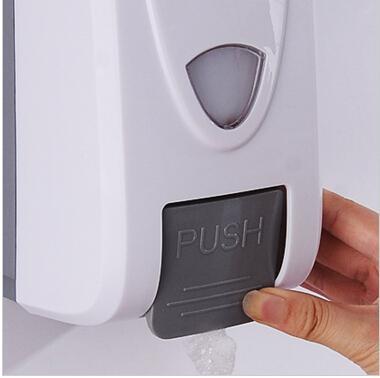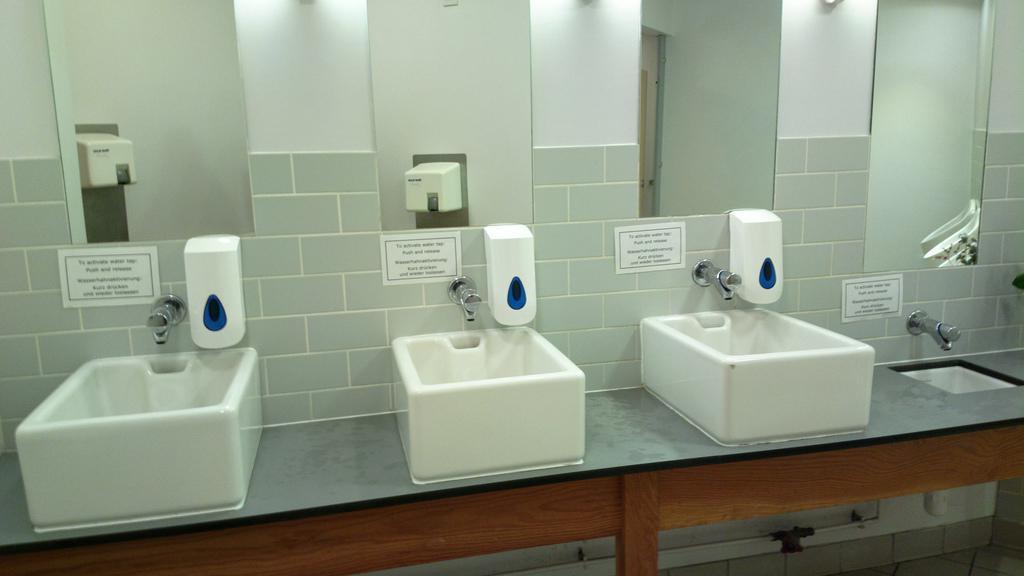The first image is the image on the left, the second image is the image on the right. Evaluate the accuracy of this statement regarding the images: "A person is pushing the dispenser in the image on the left.". Is it true? Answer yes or no. Yes. The first image is the image on the left, the second image is the image on the right. Analyze the images presented: Is the assertion "A restroom interior contains a counter with at least three identical white sinks." valid? Answer yes or no. Yes. 